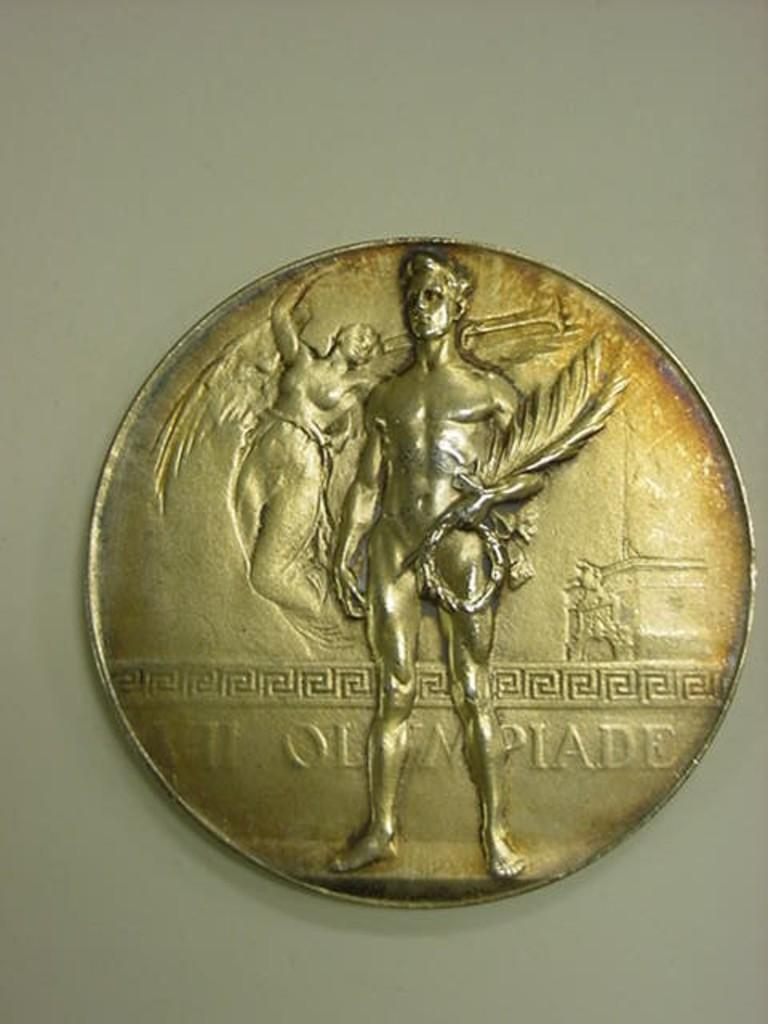<image>
Give a short and clear explanation of the subsequent image. A man and woman are depicted on a coin with the text Olympiade engraved on it. 